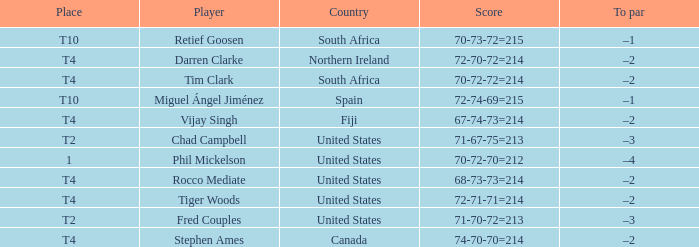What is Rocco Mediate's par? –2. 